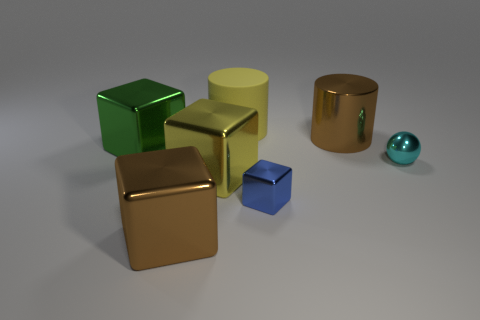Subtract all tiny blocks. How many blocks are left? 3 Subtract all purple cubes. Subtract all blue spheres. How many cubes are left? 4 Add 2 tiny cubes. How many objects exist? 9 Subtract all cylinders. How many objects are left? 5 Subtract all balls. Subtract all cyan metallic balls. How many objects are left? 5 Add 5 yellow rubber things. How many yellow rubber things are left? 6 Add 4 big brown metal things. How many big brown metal things exist? 6 Subtract 0 blue spheres. How many objects are left? 7 